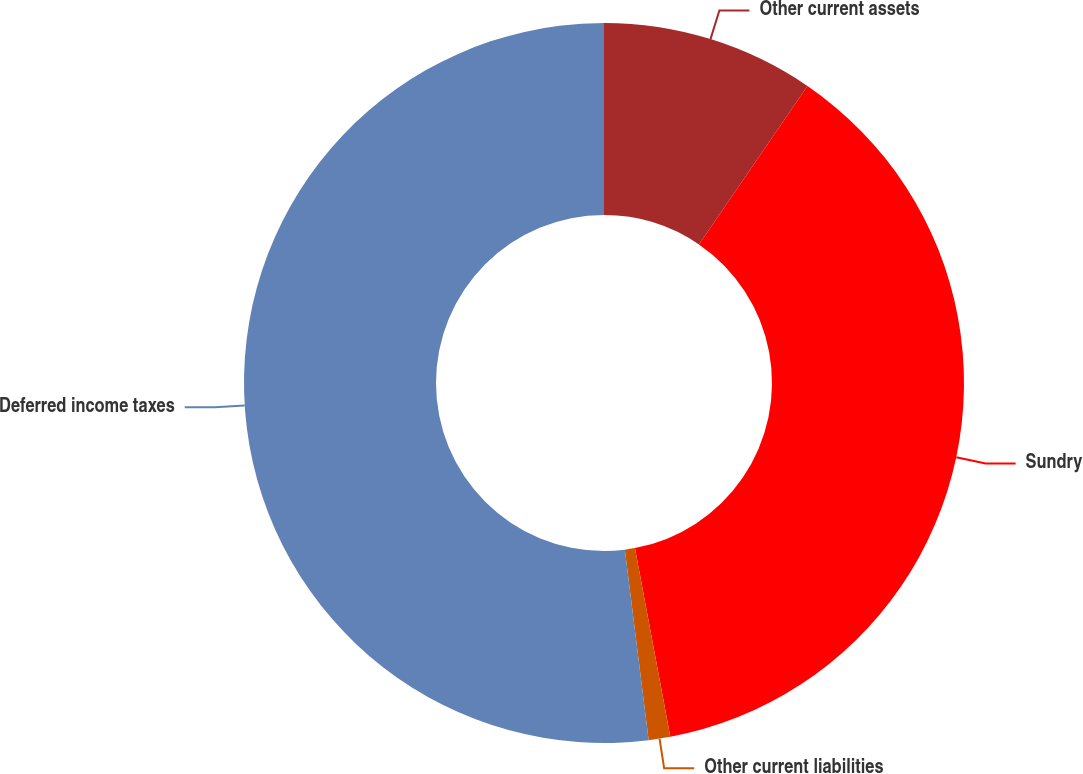Convert chart to OTSL. <chart><loc_0><loc_0><loc_500><loc_500><pie_chart><fcel>Other current assets<fcel>Sundry<fcel>Other current liabilities<fcel>Deferred income taxes<nl><fcel>9.56%<fcel>37.49%<fcel>0.97%<fcel>51.98%<nl></chart> 